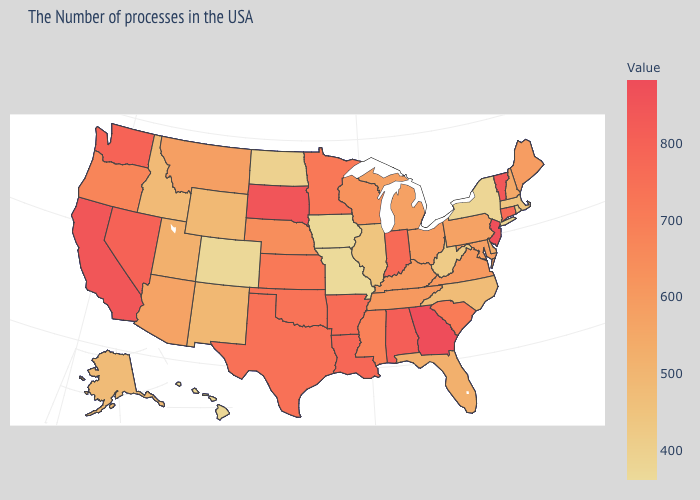Among the states that border Maryland , which have the highest value?
Short answer required. Virginia. Which states have the lowest value in the Northeast?
Write a very short answer. New York. 